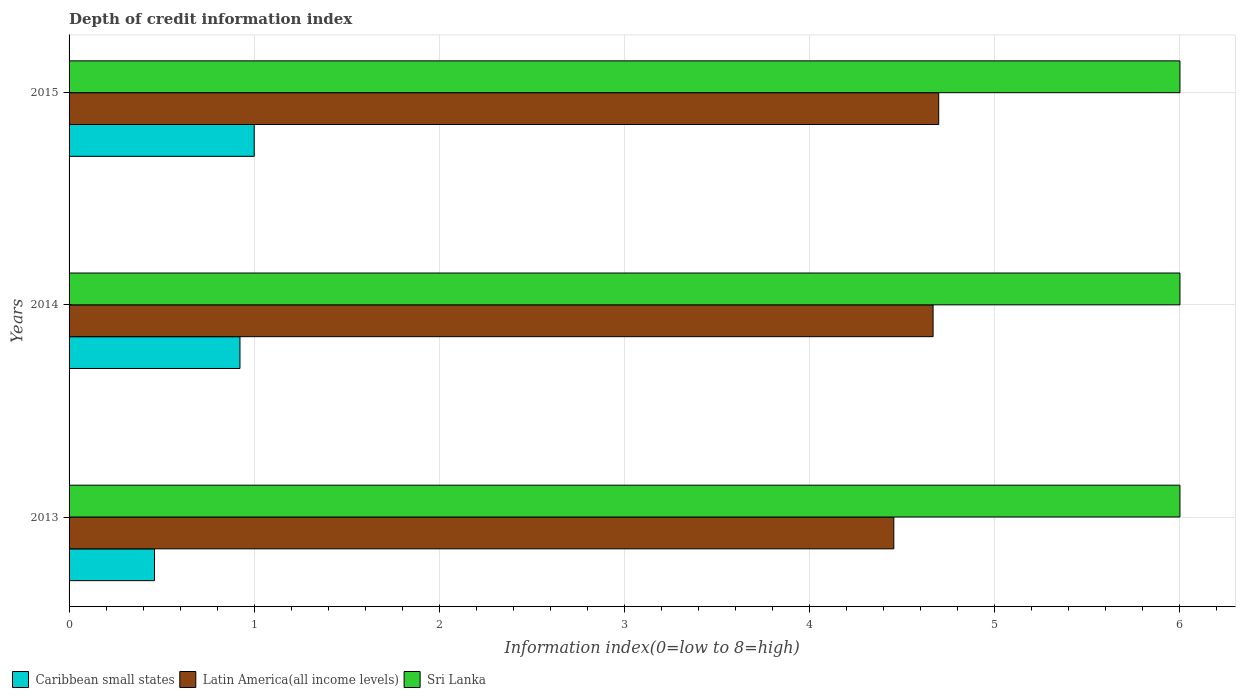How many different coloured bars are there?
Your answer should be compact. 3. How many groups of bars are there?
Ensure brevity in your answer.  3. How many bars are there on the 3rd tick from the bottom?
Offer a terse response. 3. What is the label of the 1st group of bars from the top?
Keep it short and to the point. 2015. In how many cases, is the number of bars for a given year not equal to the number of legend labels?
Make the answer very short. 0. Across all years, what is the minimum information index in Latin America(all income levels)?
Make the answer very short. 4.45. In which year was the information index in Sri Lanka maximum?
Keep it short and to the point. 2013. What is the total information index in Sri Lanka in the graph?
Ensure brevity in your answer.  18. What is the difference between the information index in Caribbean small states in 2013 and that in 2014?
Offer a terse response. -0.46. What is the difference between the information index in Sri Lanka in 2014 and the information index in Latin America(all income levels) in 2013?
Keep it short and to the point. 1.55. What is the average information index in Latin America(all income levels) per year?
Give a very brief answer. 4.61. In the year 2014, what is the difference between the information index in Latin America(all income levels) and information index in Sri Lanka?
Your answer should be compact. -1.33. In how many years, is the information index in Latin America(all income levels) greater than 5.8 ?
Keep it short and to the point. 0. What is the ratio of the information index in Latin America(all income levels) in 2013 to that in 2015?
Offer a very short reply. 0.95. Is the information index in Sri Lanka in 2013 less than that in 2014?
Your answer should be very brief. No. What is the difference between the highest and the lowest information index in Sri Lanka?
Give a very brief answer. 0. What does the 1st bar from the top in 2013 represents?
Your response must be concise. Sri Lanka. What does the 2nd bar from the bottom in 2013 represents?
Make the answer very short. Latin America(all income levels). Is it the case that in every year, the sum of the information index in Latin America(all income levels) and information index in Caribbean small states is greater than the information index in Sri Lanka?
Provide a short and direct response. No. Are all the bars in the graph horizontal?
Provide a succinct answer. Yes. How many years are there in the graph?
Give a very brief answer. 3. What is the difference between two consecutive major ticks on the X-axis?
Offer a terse response. 1. Are the values on the major ticks of X-axis written in scientific E-notation?
Provide a short and direct response. No. Does the graph contain any zero values?
Give a very brief answer. No. Where does the legend appear in the graph?
Ensure brevity in your answer.  Bottom left. How many legend labels are there?
Your response must be concise. 3. What is the title of the graph?
Offer a terse response. Depth of credit information index. Does "United States" appear as one of the legend labels in the graph?
Keep it short and to the point. No. What is the label or title of the X-axis?
Give a very brief answer. Information index(0=low to 8=high). What is the label or title of the Y-axis?
Keep it short and to the point. Years. What is the Information index(0=low to 8=high) of Caribbean small states in 2013?
Your answer should be compact. 0.46. What is the Information index(0=low to 8=high) of Latin America(all income levels) in 2013?
Provide a succinct answer. 4.45. What is the Information index(0=low to 8=high) of Sri Lanka in 2013?
Ensure brevity in your answer.  6. What is the Information index(0=low to 8=high) in Caribbean small states in 2014?
Give a very brief answer. 0.92. What is the Information index(0=low to 8=high) of Latin America(all income levels) in 2014?
Keep it short and to the point. 4.67. What is the Information index(0=low to 8=high) of Sri Lanka in 2014?
Offer a terse response. 6. What is the Information index(0=low to 8=high) of Latin America(all income levels) in 2015?
Keep it short and to the point. 4.7. What is the Information index(0=low to 8=high) in Sri Lanka in 2015?
Your answer should be compact. 6. Across all years, what is the maximum Information index(0=low to 8=high) of Latin America(all income levels)?
Ensure brevity in your answer.  4.7. Across all years, what is the maximum Information index(0=low to 8=high) in Sri Lanka?
Your response must be concise. 6. Across all years, what is the minimum Information index(0=low to 8=high) in Caribbean small states?
Provide a succinct answer. 0.46. Across all years, what is the minimum Information index(0=low to 8=high) in Latin America(all income levels)?
Provide a succinct answer. 4.45. What is the total Information index(0=low to 8=high) in Caribbean small states in the graph?
Provide a short and direct response. 2.38. What is the total Information index(0=low to 8=high) of Latin America(all income levels) in the graph?
Provide a short and direct response. 13.82. What is the difference between the Information index(0=low to 8=high) in Caribbean small states in 2013 and that in 2014?
Ensure brevity in your answer.  -0.46. What is the difference between the Information index(0=low to 8=high) in Latin America(all income levels) in 2013 and that in 2014?
Your answer should be compact. -0.21. What is the difference between the Information index(0=low to 8=high) in Sri Lanka in 2013 and that in 2014?
Ensure brevity in your answer.  0. What is the difference between the Information index(0=low to 8=high) of Caribbean small states in 2013 and that in 2015?
Give a very brief answer. -0.54. What is the difference between the Information index(0=low to 8=high) of Latin America(all income levels) in 2013 and that in 2015?
Offer a terse response. -0.24. What is the difference between the Information index(0=low to 8=high) of Caribbean small states in 2014 and that in 2015?
Make the answer very short. -0.08. What is the difference between the Information index(0=low to 8=high) in Latin America(all income levels) in 2014 and that in 2015?
Offer a terse response. -0.03. What is the difference between the Information index(0=low to 8=high) in Caribbean small states in 2013 and the Information index(0=low to 8=high) in Latin America(all income levels) in 2014?
Your answer should be very brief. -4.21. What is the difference between the Information index(0=low to 8=high) in Caribbean small states in 2013 and the Information index(0=low to 8=high) in Sri Lanka in 2014?
Your response must be concise. -5.54. What is the difference between the Information index(0=low to 8=high) of Latin America(all income levels) in 2013 and the Information index(0=low to 8=high) of Sri Lanka in 2014?
Your answer should be compact. -1.55. What is the difference between the Information index(0=low to 8=high) of Caribbean small states in 2013 and the Information index(0=low to 8=high) of Latin America(all income levels) in 2015?
Your response must be concise. -4.24. What is the difference between the Information index(0=low to 8=high) in Caribbean small states in 2013 and the Information index(0=low to 8=high) in Sri Lanka in 2015?
Give a very brief answer. -5.54. What is the difference between the Information index(0=low to 8=high) of Latin America(all income levels) in 2013 and the Information index(0=low to 8=high) of Sri Lanka in 2015?
Offer a terse response. -1.55. What is the difference between the Information index(0=low to 8=high) of Caribbean small states in 2014 and the Information index(0=low to 8=high) of Latin America(all income levels) in 2015?
Keep it short and to the point. -3.77. What is the difference between the Information index(0=low to 8=high) of Caribbean small states in 2014 and the Information index(0=low to 8=high) of Sri Lanka in 2015?
Offer a terse response. -5.08. What is the difference between the Information index(0=low to 8=high) in Latin America(all income levels) in 2014 and the Information index(0=low to 8=high) in Sri Lanka in 2015?
Provide a short and direct response. -1.33. What is the average Information index(0=low to 8=high) in Caribbean small states per year?
Offer a very short reply. 0.79. What is the average Information index(0=low to 8=high) of Latin America(all income levels) per year?
Your response must be concise. 4.61. In the year 2013, what is the difference between the Information index(0=low to 8=high) in Caribbean small states and Information index(0=low to 8=high) in Latin America(all income levels)?
Your answer should be very brief. -3.99. In the year 2013, what is the difference between the Information index(0=low to 8=high) in Caribbean small states and Information index(0=low to 8=high) in Sri Lanka?
Your answer should be compact. -5.54. In the year 2013, what is the difference between the Information index(0=low to 8=high) of Latin America(all income levels) and Information index(0=low to 8=high) of Sri Lanka?
Provide a succinct answer. -1.55. In the year 2014, what is the difference between the Information index(0=low to 8=high) of Caribbean small states and Information index(0=low to 8=high) of Latin America(all income levels)?
Keep it short and to the point. -3.74. In the year 2014, what is the difference between the Information index(0=low to 8=high) in Caribbean small states and Information index(0=low to 8=high) in Sri Lanka?
Give a very brief answer. -5.08. In the year 2014, what is the difference between the Information index(0=low to 8=high) in Latin America(all income levels) and Information index(0=low to 8=high) in Sri Lanka?
Ensure brevity in your answer.  -1.33. In the year 2015, what is the difference between the Information index(0=low to 8=high) of Caribbean small states and Information index(0=low to 8=high) of Latin America(all income levels)?
Offer a very short reply. -3.7. In the year 2015, what is the difference between the Information index(0=low to 8=high) in Caribbean small states and Information index(0=low to 8=high) in Sri Lanka?
Ensure brevity in your answer.  -5. In the year 2015, what is the difference between the Information index(0=low to 8=high) of Latin America(all income levels) and Information index(0=low to 8=high) of Sri Lanka?
Offer a very short reply. -1.3. What is the ratio of the Information index(0=low to 8=high) in Latin America(all income levels) in 2013 to that in 2014?
Make the answer very short. 0.95. What is the ratio of the Information index(0=low to 8=high) of Sri Lanka in 2013 to that in 2014?
Your answer should be very brief. 1. What is the ratio of the Information index(0=low to 8=high) in Caribbean small states in 2013 to that in 2015?
Offer a terse response. 0.46. What is the ratio of the Information index(0=low to 8=high) in Latin America(all income levels) in 2013 to that in 2015?
Offer a terse response. 0.95. What is the ratio of the Information index(0=low to 8=high) of Sri Lanka in 2013 to that in 2015?
Your answer should be compact. 1. What is the difference between the highest and the second highest Information index(0=low to 8=high) in Caribbean small states?
Provide a short and direct response. 0.08. What is the difference between the highest and the second highest Information index(0=low to 8=high) of Latin America(all income levels)?
Ensure brevity in your answer.  0.03. What is the difference between the highest and the lowest Information index(0=low to 8=high) in Caribbean small states?
Your response must be concise. 0.54. What is the difference between the highest and the lowest Information index(0=low to 8=high) in Latin America(all income levels)?
Your answer should be compact. 0.24. 